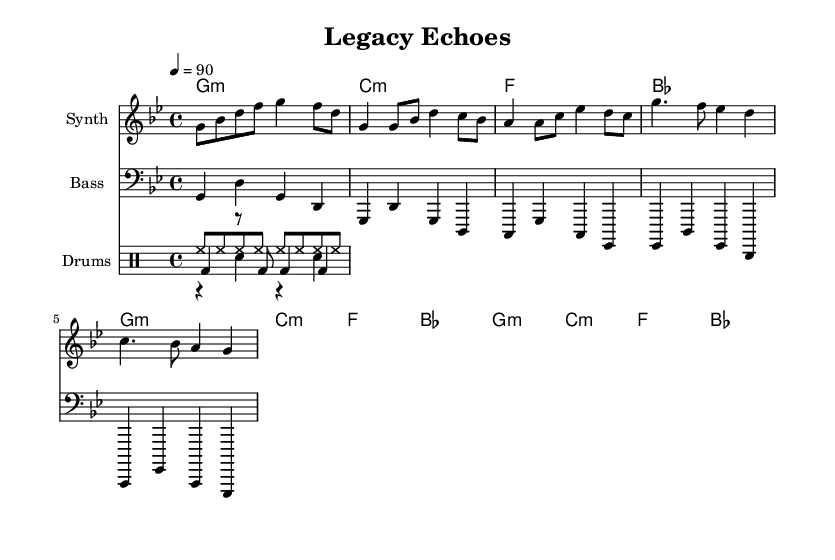what is the key signature of this music? The key signature is G minor, which has two flats (B♭ and E♭) indicated in the music staff.
Answer: G minor what is the time signature of this music? The time signature is 4/4, which indicates four beats per measure and is shown at the beginning of the sheet music.
Answer: 4/4 what is the tempo of this music? The tempo is indicated as a quarter note equals 90, showing the speed at which the piece should be played.
Answer: 90 how many measures are in the intro section of the music? The intro section consists of one measure as indicated by the notation and rhythmic markers at the beginning of the piece.
Answer: 1 what rhythmic pattern is used for the hi-hat in the drum part? The hi-hat plays a continuous eighth-note pattern throughout the piece, as shown by the repeated symbol in a steady rhythm.
Answer: Eighth notes how does the bass line relate to the melody in the first verse? The bass line mirrors the melody's rhythmic patterns but is played an octave lower, providing harmonic support while maintaining interaction with the melody.
Answer: Mirrors rhythm what type of instruments are indicated in the score? The score indicates a Synth for melody, Bass for the lower harmony, and Drums for the rhythm section.
Answer: Synth, Bass, Drums 